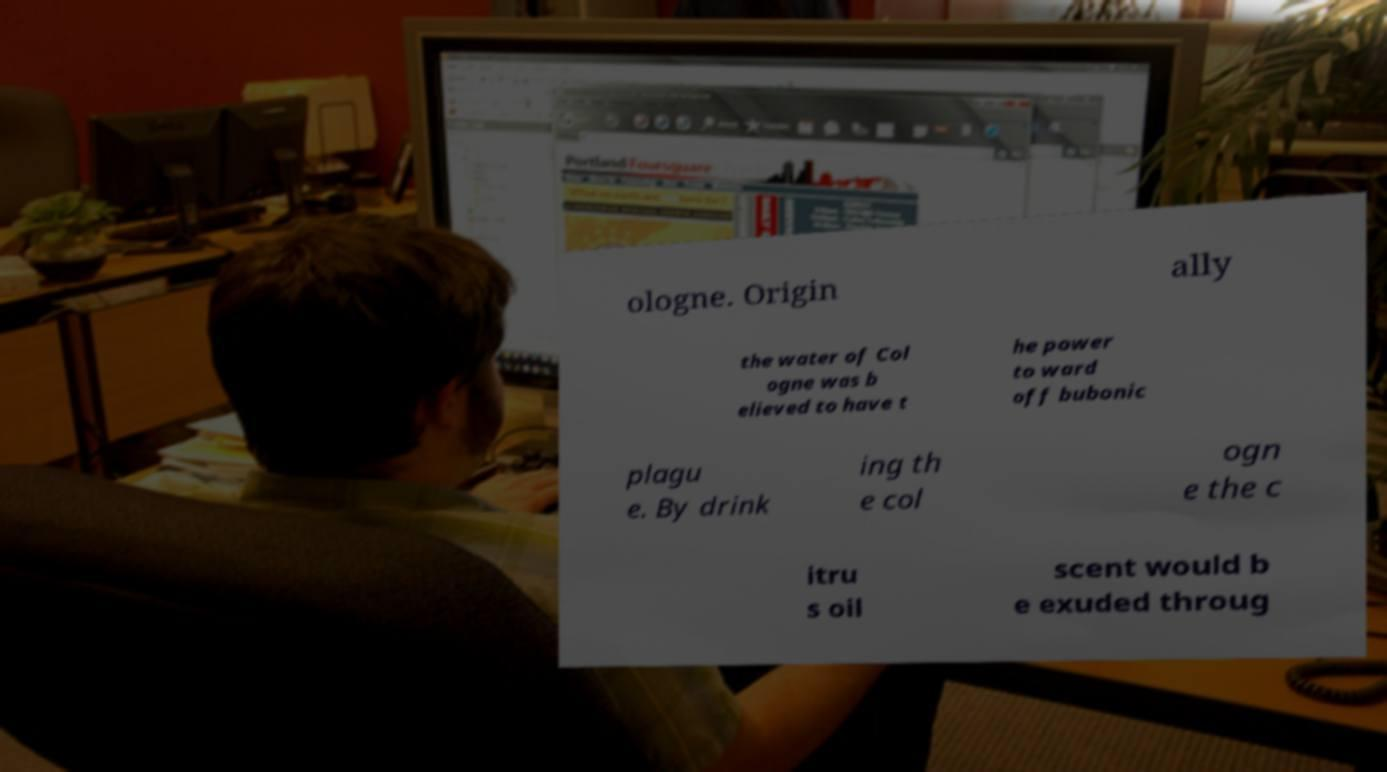Please identify and transcribe the text found in this image. ologne. Origin ally the water of Col ogne was b elieved to have t he power to ward off bubonic plagu e. By drink ing th e col ogn e the c itru s oil scent would b e exuded throug 